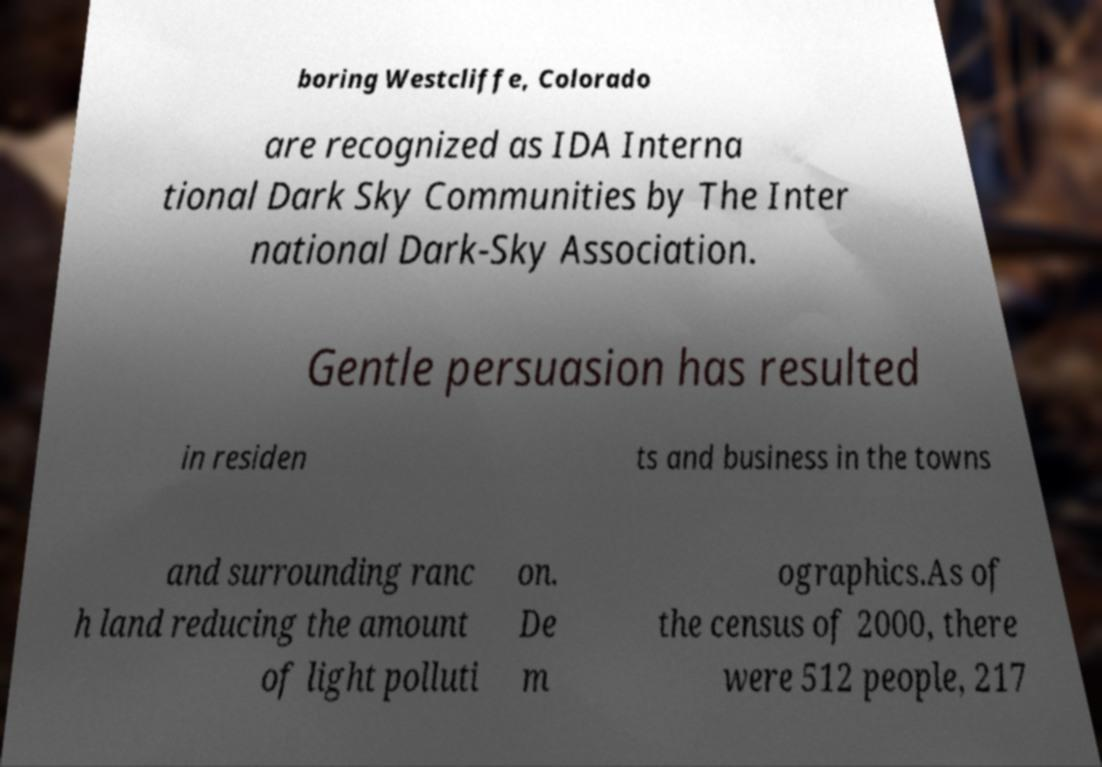What messages or text are displayed in this image? I need them in a readable, typed format. boring Westcliffe, Colorado are recognized as IDA Interna tional Dark Sky Communities by The Inter national Dark-Sky Association. Gentle persuasion has resulted in residen ts and business in the towns and surrounding ranc h land reducing the amount of light polluti on. De m ographics.As of the census of 2000, there were 512 people, 217 